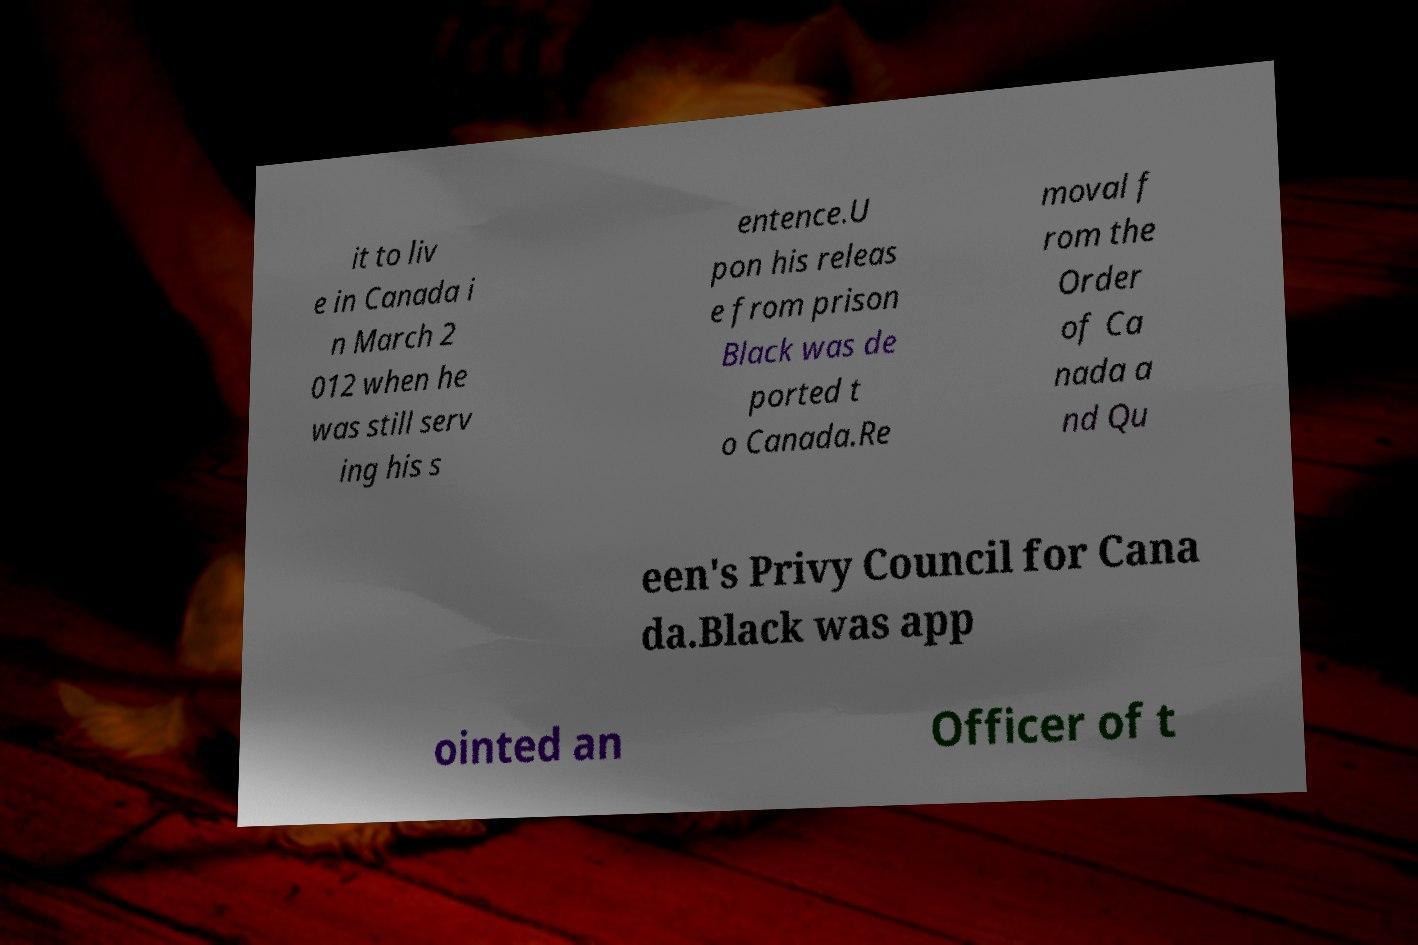Could you extract and type out the text from this image? it to liv e in Canada i n March 2 012 when he was still serv ing his s entence.U pon his releas e from prison Black was de ported t o Canada.Re moval f rom the Order of Ca nada a nd Qu een's Privy Council for Cana da.Black was app ointed an Officer of t 